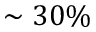<formula> <loc_0><loc_0><loc_500><loc_500>\sim 3 0 \%</formula> 